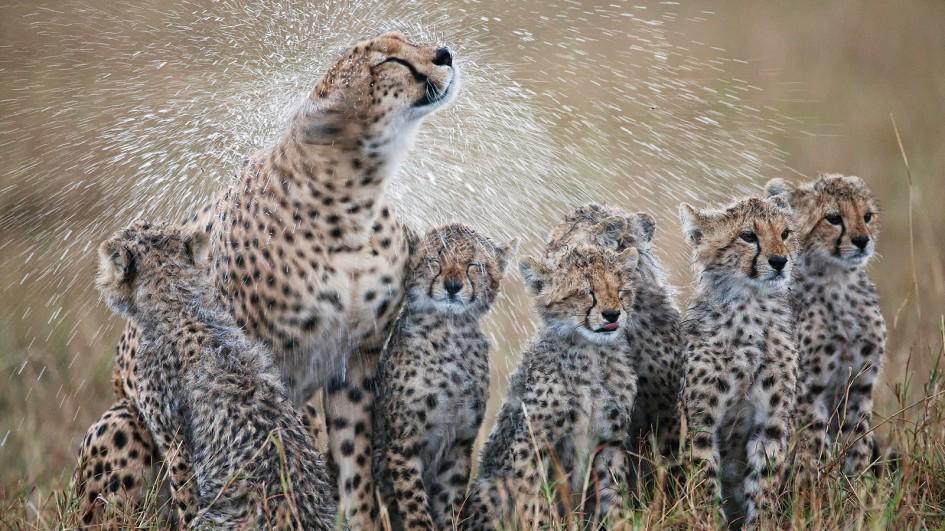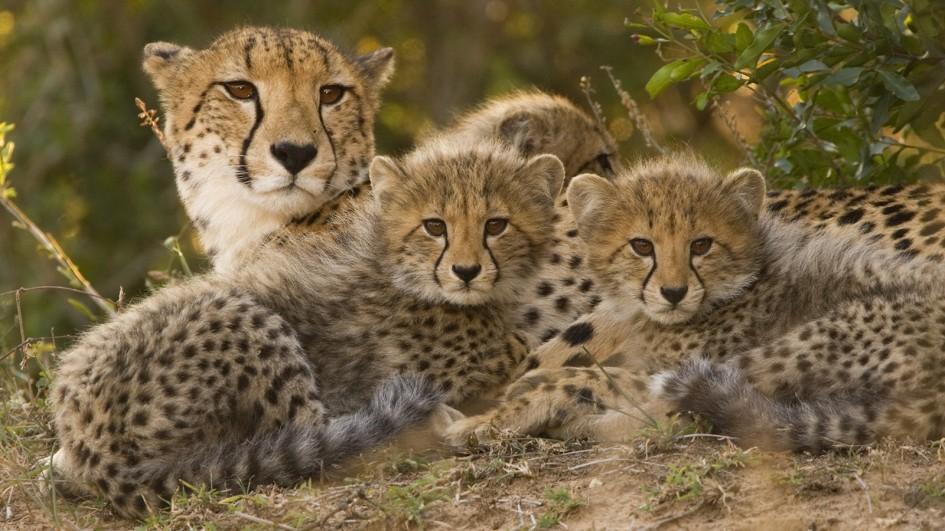The first image is the image on the left, the second image is the image on the right. Examine the images to the left and right. Is the description "A total of five cheetahs are shown between the two images." accurate? Answer yes or no. No. 